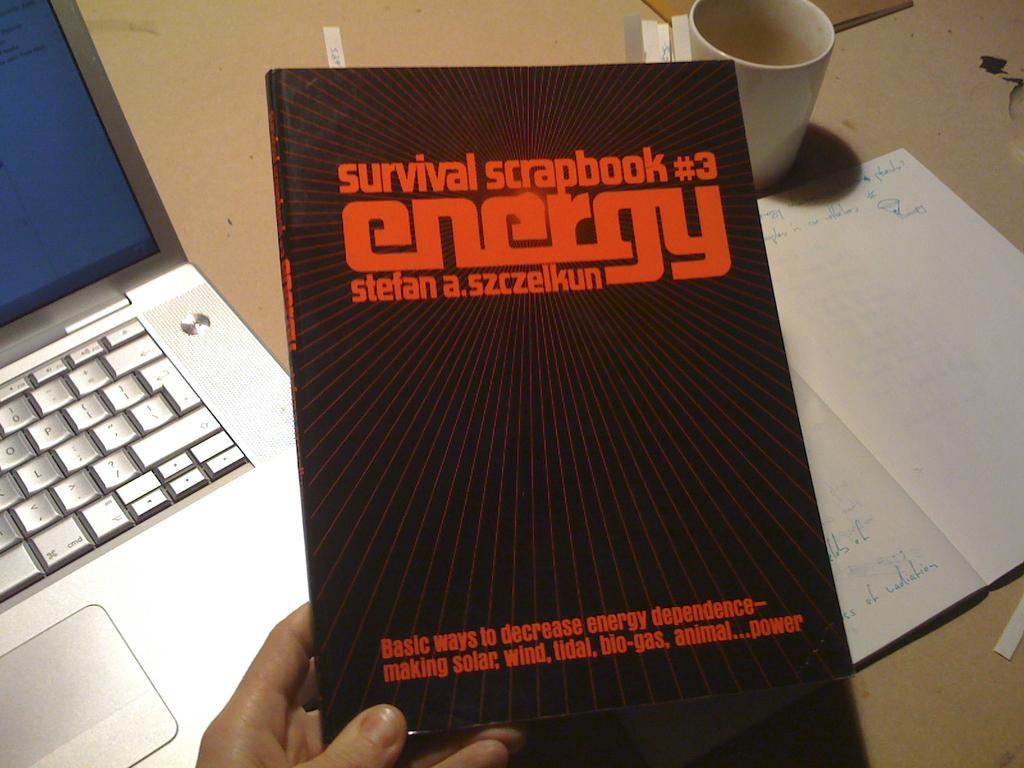<image>
Give a short and clear explanation of the subsequent image. The cover of the Survival Scrapbook #3 Energy. 